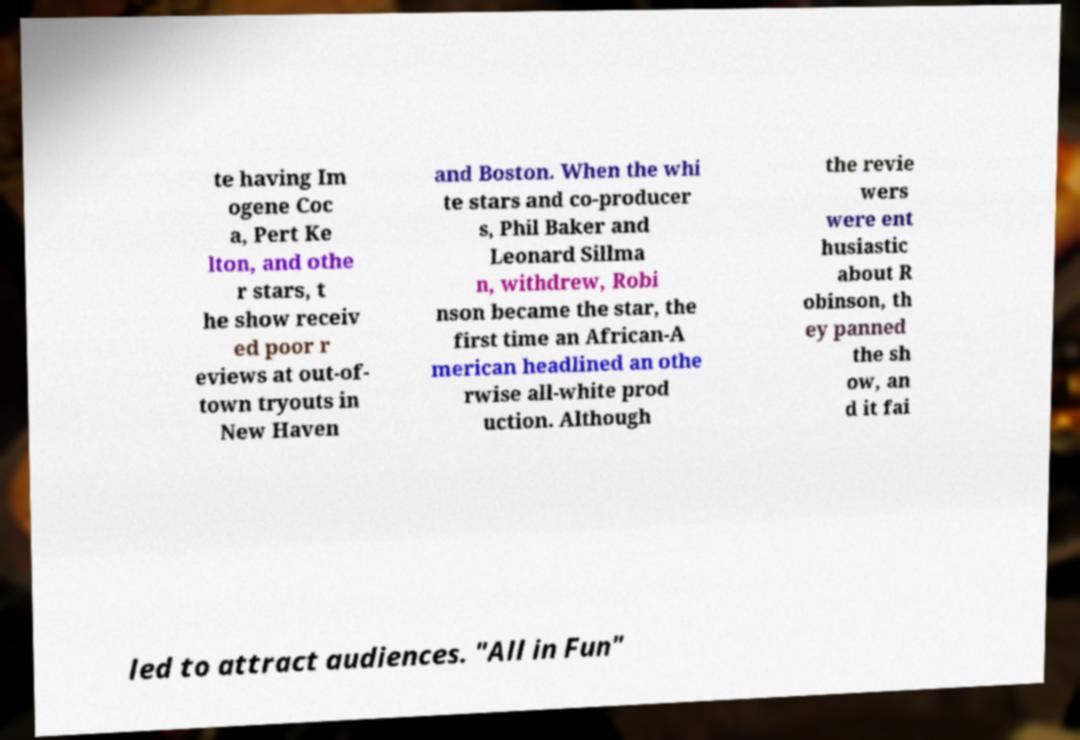Please read and relay the text visible in this image. What does it say? te having Im ogene Coc a, Pert Ke lton, and othe r stars, t he show receiv ed poor r eviews at out-of- town tryouts in New Haven and Boston. When the whi te stars and co-producer s, Phil Baker and Leonard Sillma n, withdrew, Robi nson became the star, the first time an African-A merican headlined an othe rwise all-white prod uction. Although the revie wers were ent husiastic about R obinson, th ey panned the sh ow, an d it fai led to attract audiences. "All in Fun" 